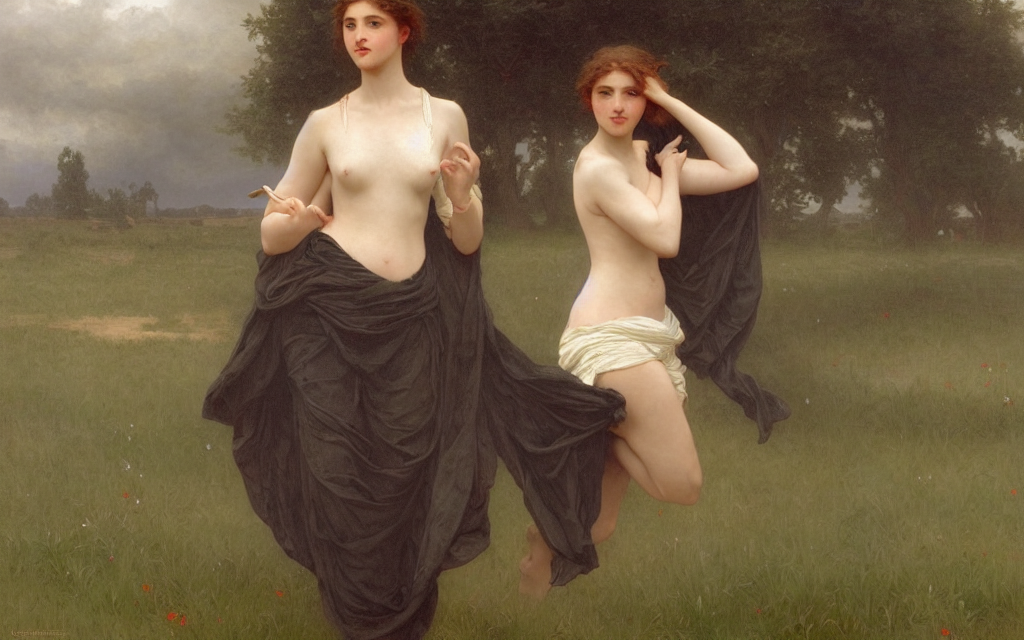Is the texture of the skin relatively clear? Yes, the texture of the skin appears quite clear, displaying a smooth and refined quality that is typical of classical painting methods. This well-executed representation suggests a meticulous attention to detail from the artist. 